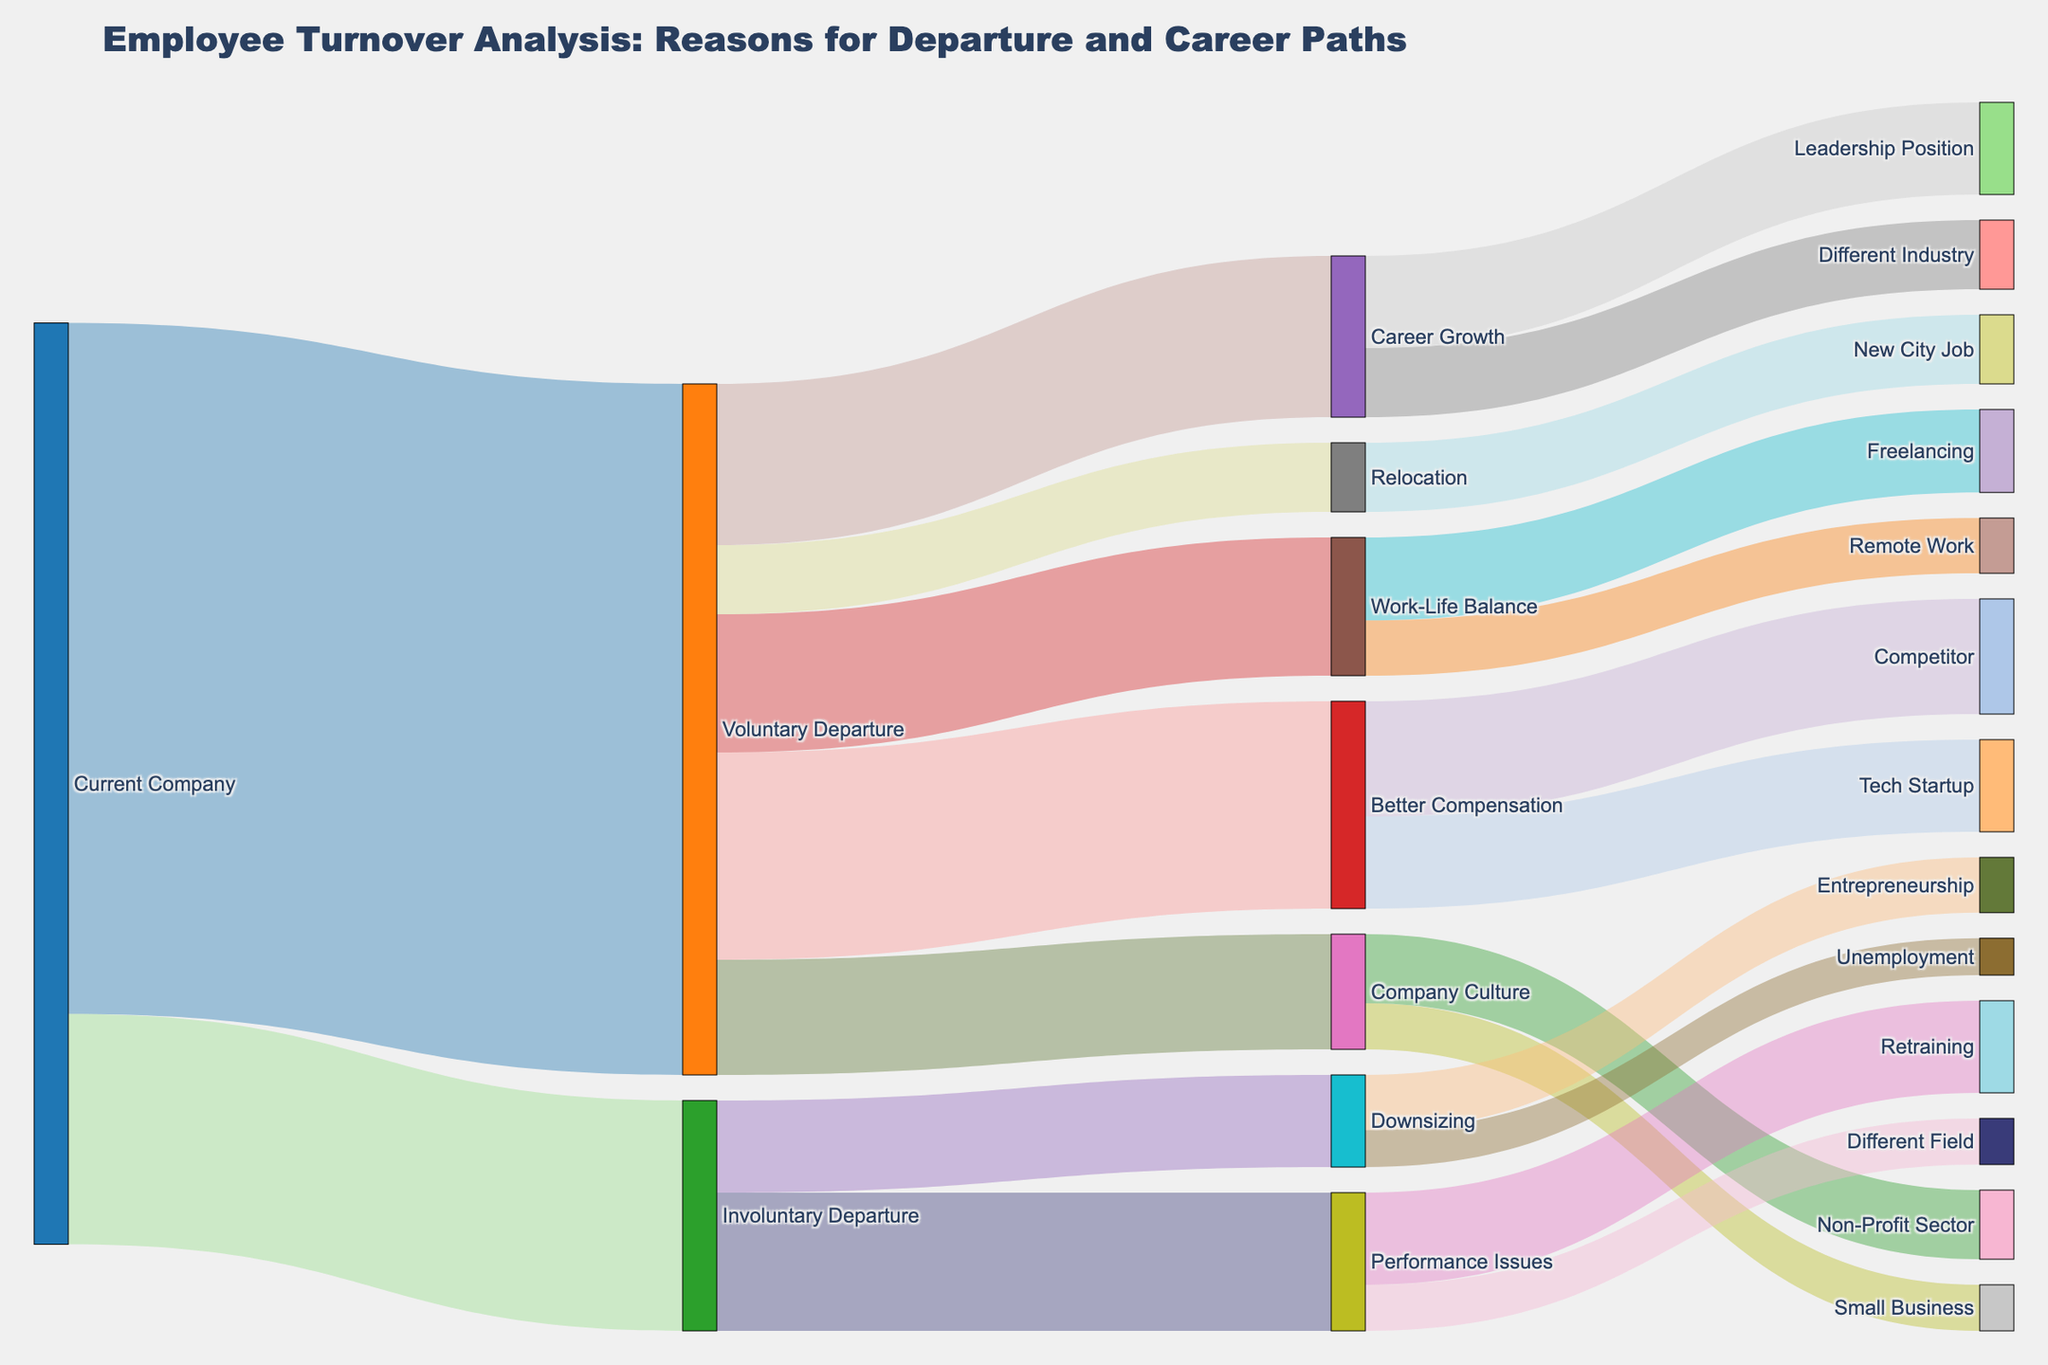Who had the highest number of departures from the current company: voluntary or involuntary? By comparing the values, we can see that voluntary departure has 150 people while involuntary departure has 50 people. Voluntary departure is the higher number.
Answer: Voluntary departure What is the total number of employees who left for better compensation and career growth combined? Sum the values for employees who left for better compensation (45) and those who left for career growth (35): 45 + 35 = 80
Answer: 80 Which specific path under voluntary departure has the lowest number of employees? By looking at the targets under voluntary departure, relocation has the lowest number at 15.
Answer: Relocation How many employees went to freelancing or remote work for better work-life balance? Sum the values for employees who went to freelancing (18) and remote work (12): 18 + 12 = 30
Answer: 30 Which reason under involuntary departure has more employees: performance issues or downsizing? Comparing the values, performance issues has 30 employees while downsizing has 20 employees. Performance issues is greater.
Answer: Performance issues What is the total number of employees who left due to involuntary departure and went into entrepreneurship or unemployment? Sum the values for employees who went into entrepreneurship (12) and unemployment (8): 12 + 8 = 20
Answer: 20 How many employees left for career growth and moved into a leadership position? The value showing employees who left for career growth and moved into a leadership position is 20.
Answer: 20 What is the total number of employees who switched to competitors and tech startups combined for better compensation? Sum the values for employees who switched to competitors (25) and tech startups (20): 25 + 20 = 45
Answer: 45 Which exit reason from the current company has more people: better compensation or work-life balance? Better compensation has 45 people, and work-life balance has 30 people. Better compensation is greater.
Answer: Better compensation How many employees who left due to performance issues went through retraining? The value showing employees who left due to performance issues and went through retraining is 20.
Answer: 20 